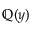Convert formula to latex. <formula><loc_0><loc_0><loc_500><loc_500>\mathbb { Q } ( y )</formula> 